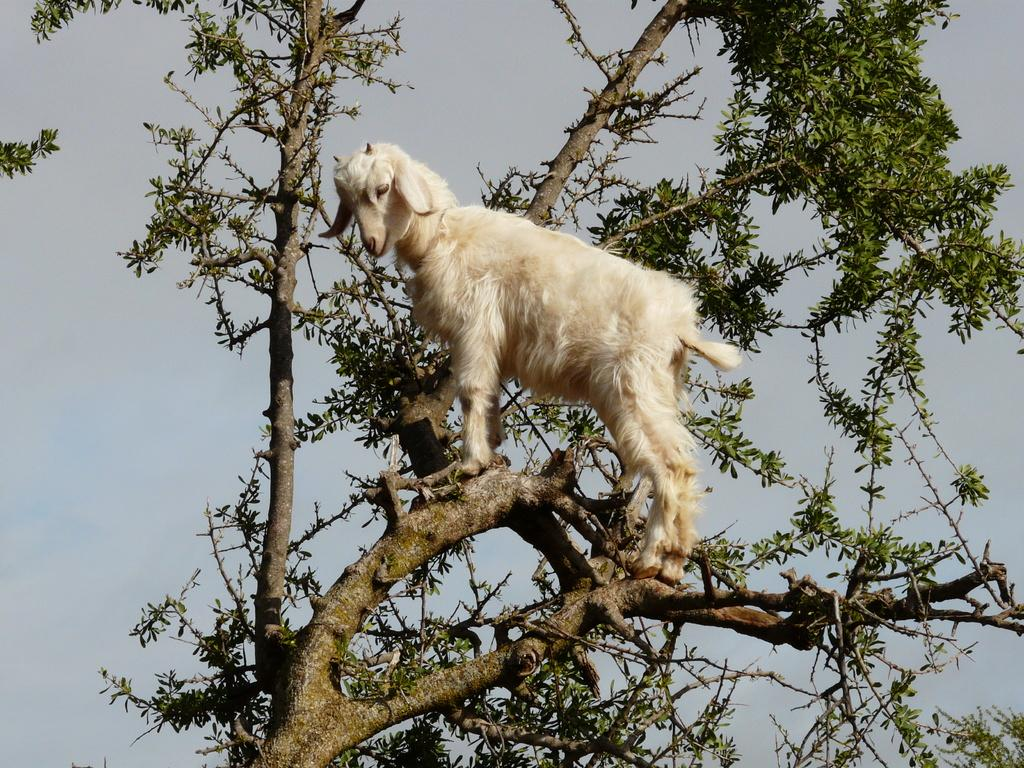What is the main object in the picture? There is a tree in the picture. What is on the tree? A goat is on a branch of the tree. What can be seen in the sky? There are clouds in the sky. What type of sock is the goat wearing on its front leg? There is no sock present on the goat's leg in the image. Is the goat swimming in the picture? No, the goat is on a branch of the tree, not swimming. 